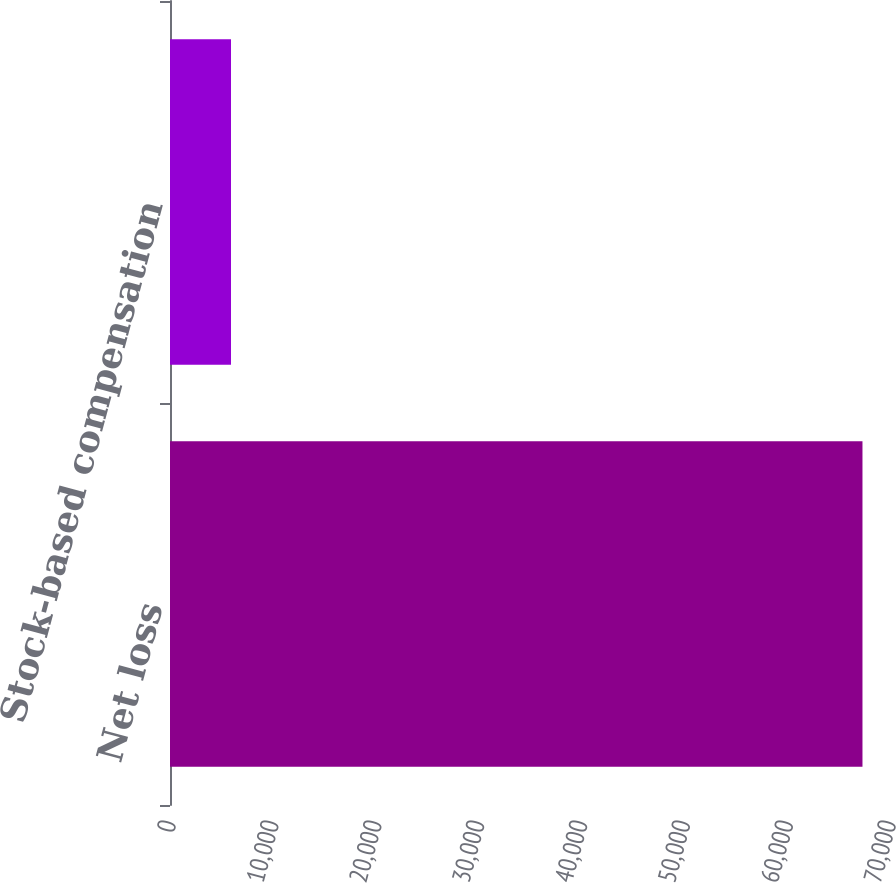Convert chart. <chart><loc_0><loc_0><loc_500><loc_500><bar_chart><fcel>Net loss<fcel>Stock-based compensation<nl><fcel>67324<fcel>5931<nl></chart> 